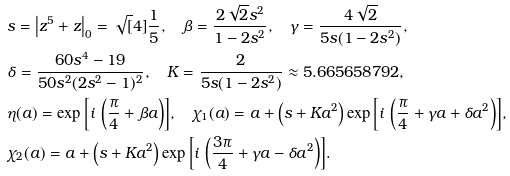Convert formula to latex. <formula><loc_0><loc_0><loc_500><loc_500>& s = \left | z ^ { 5 } + z \right | _ { 0 } = \sqrt { [ } 4 ] { \frac { 1 } { 5 } } , \quad \beta = \frac { 2 \sqrt { 2 } s ^ { 2 } } { 1 - 2 s ^ { 2 } } , \quad \gamma = \frac { 4 \sqrt { 2 } } { 5 s ( 1 - 2 s ^ { 2 } ) } , \\ & \delta = \frac { 6 0 s ^ { 4 } - 1 9 } { 5 0 s ^ { 2 } ( 2 s ^ { 2 } - 1 ) ^ { 2 } } , \quad K = \frac { 2 } { 5 s ( 1 - 2 s ^ { 2 } ) } \approx 5 . 6 6 5 6 5 8 7 9 2 , \\ & \eta ( a ) = \exp { \left [ i \, \left ( \frac { \pi } { 4 } + \beta a \right ) \right ] } , \quad \chi _ { 1 } ( a ) = a + \left ( s + K a ^ { 2 } \right ) \exp { \left [ i \, \left ( \frac { \pi } { 4 } + \gamma a + \delta a ^ { 2 } \right ) \right ] } , \\ & \chi _ { 2 } ( a ) = a + \left ( s + K a ^ { 2 } \right ) \exp { \left [ i \, \left ( \frac { 3 \pi } { 4 } + \gamma a - \delta a ^ { 2 } \right ) \right ] } .</formula> 